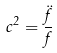Convert formula to latex. <formula><loc_0><loc_0><loc_500><loc_500>c ^ { 2 } = \frac { \ddot { f } } { f }</formula> 